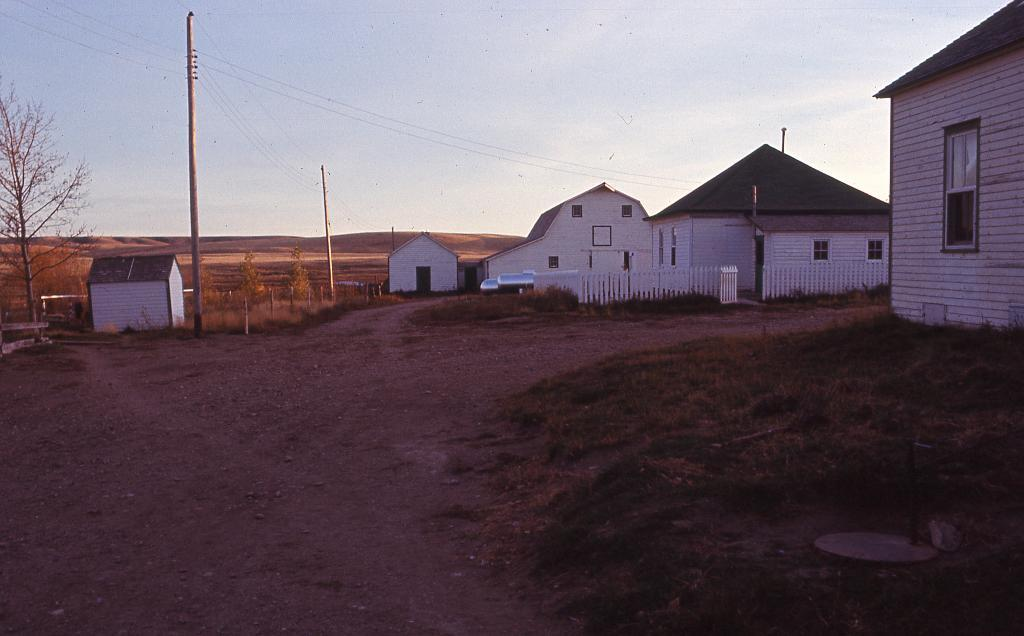What type of structures can be seen in the image? There are buildings in the image. What else can be seen in the image besides the buildings? Poles, cables, a fence, and trees are visible in the image. What is the background of the image? The sky is visible in the background of the image. What type of music can be heard playing in the garden in the image? There is no garden or music present in the image; it features buildings, poles, cables, a fence, trees, and the sky. 